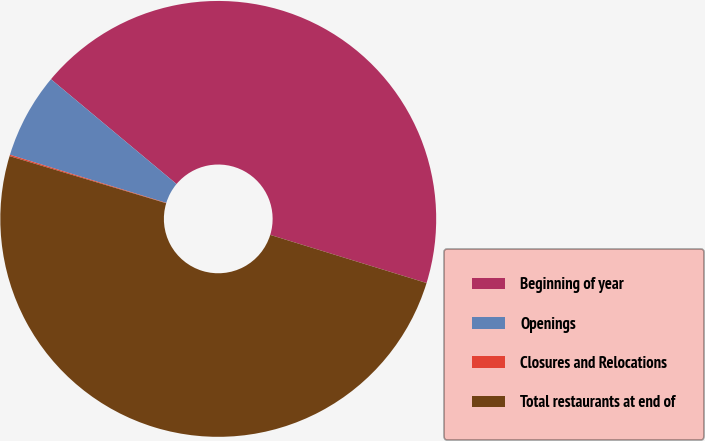Convert chart to OTSL. <chart><loc_0><loc_0><loc_500><loc_500><pie_chart><fcel>Beginning of year<fcel>Openings<fcel>Closures and Relocations<fcel>Total restaurants at end of<nl><fcel>43.68%<fcel>6.32%<fcel>0.1%<fcel>49.9%<nl></chart> 